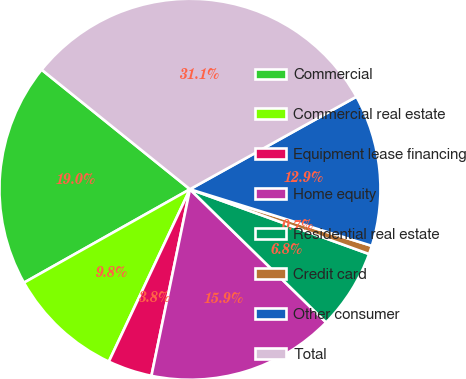Convert chart to OTSL. <chart><loc_0><loc_0><loc_500><loc_500><pie_chart><fcel>Commercial<fcel>Commercial real estate<fcel>Equipment lease financing<fcel>Home equity<fcel>Residential real estate<fcel>Credit card<fcel>Other consumer<fcel>Total<nl><fcel>18.96%<fcel>9.84%<fcel>3.76%<fcel>15.92%<fcel>6.8%<fcel>0.72%<fcel>12.88%<fcel>31.13%<nl></chart> 